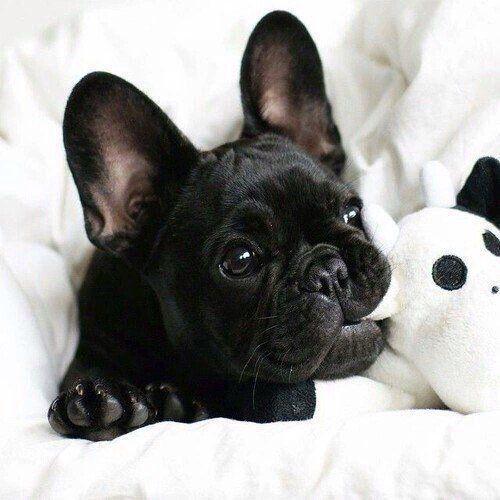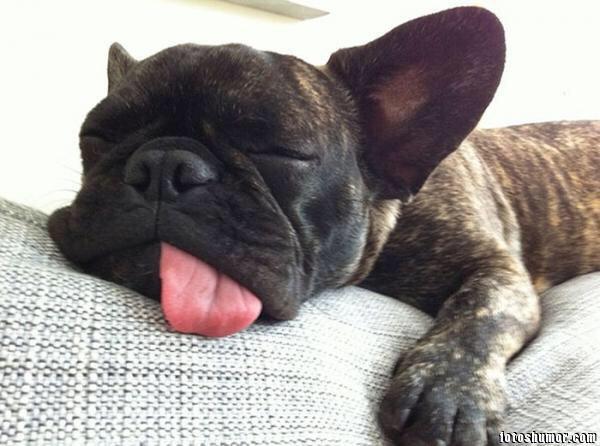The first image is the image on the left, the second image is the image on the right. For the images displayed, is the sentence "The left image shows a black french bulldog pup posed with another animal figure with upright ears." factually correct? Answer yes or no. Yes. The first image is the image on the left, the second image is the image on the right. For the images shown, is this caption "One dog has something in his mouth." true? Answer yes or no. Yes. 